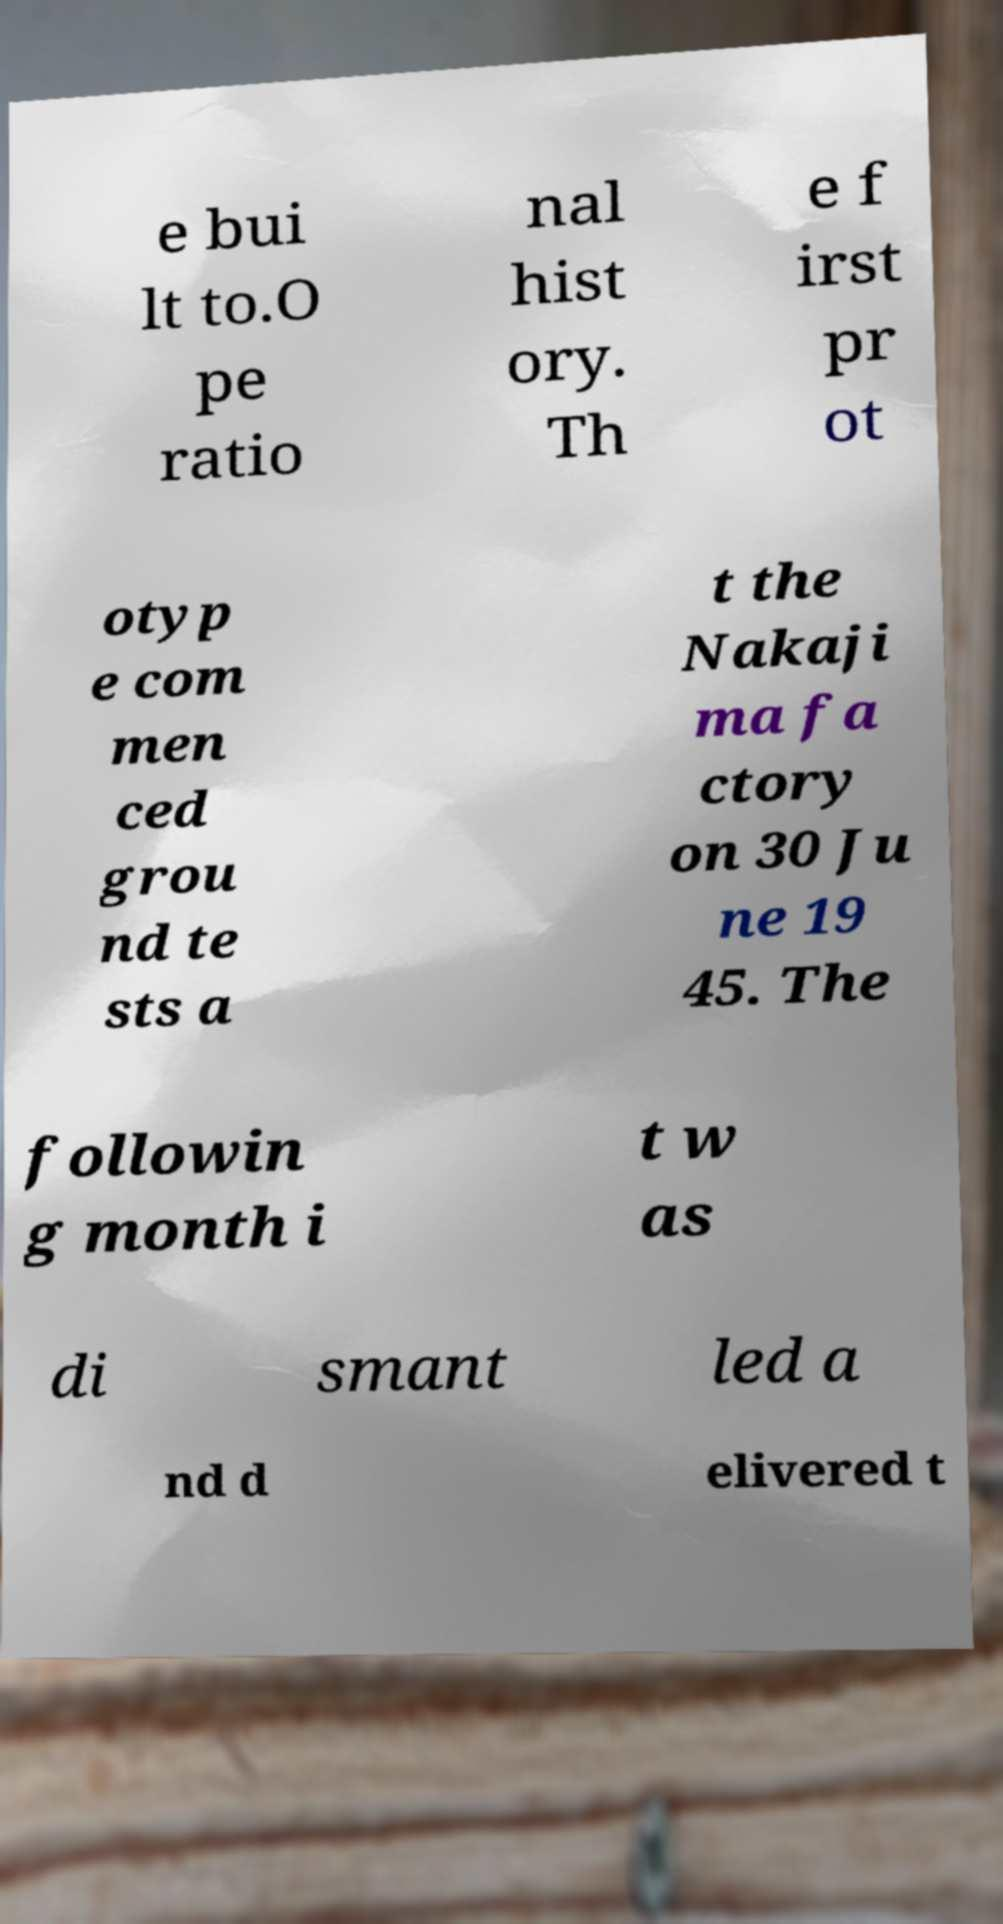Could you extract and type out the text from this image? e bui lt to.O pe ratio nal hist ory. Th e f irst pr ot otyp e com men ced grou nd te sts a t the Nakaji ma fa ctory on 30 Ju ne 19 45. The followin g month i t w as di smant led a nd d elivered t 